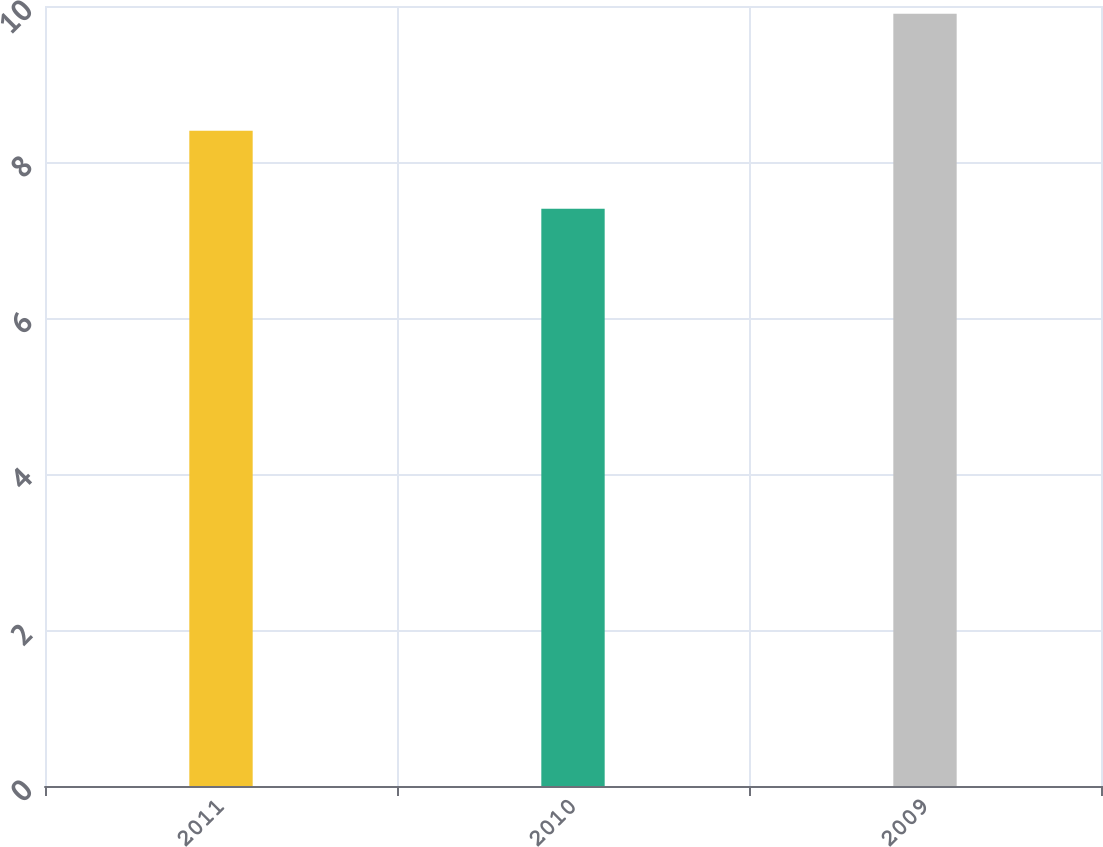Convert chart to OTSL. <chart><loc_0><loc_0><loc_500><loc_500><bar_chart><fcel>2011<fcel>2010<fcel>2009<nl><fcel>8.4<fcel>7.4<fcel>9.9<nl></chart> 